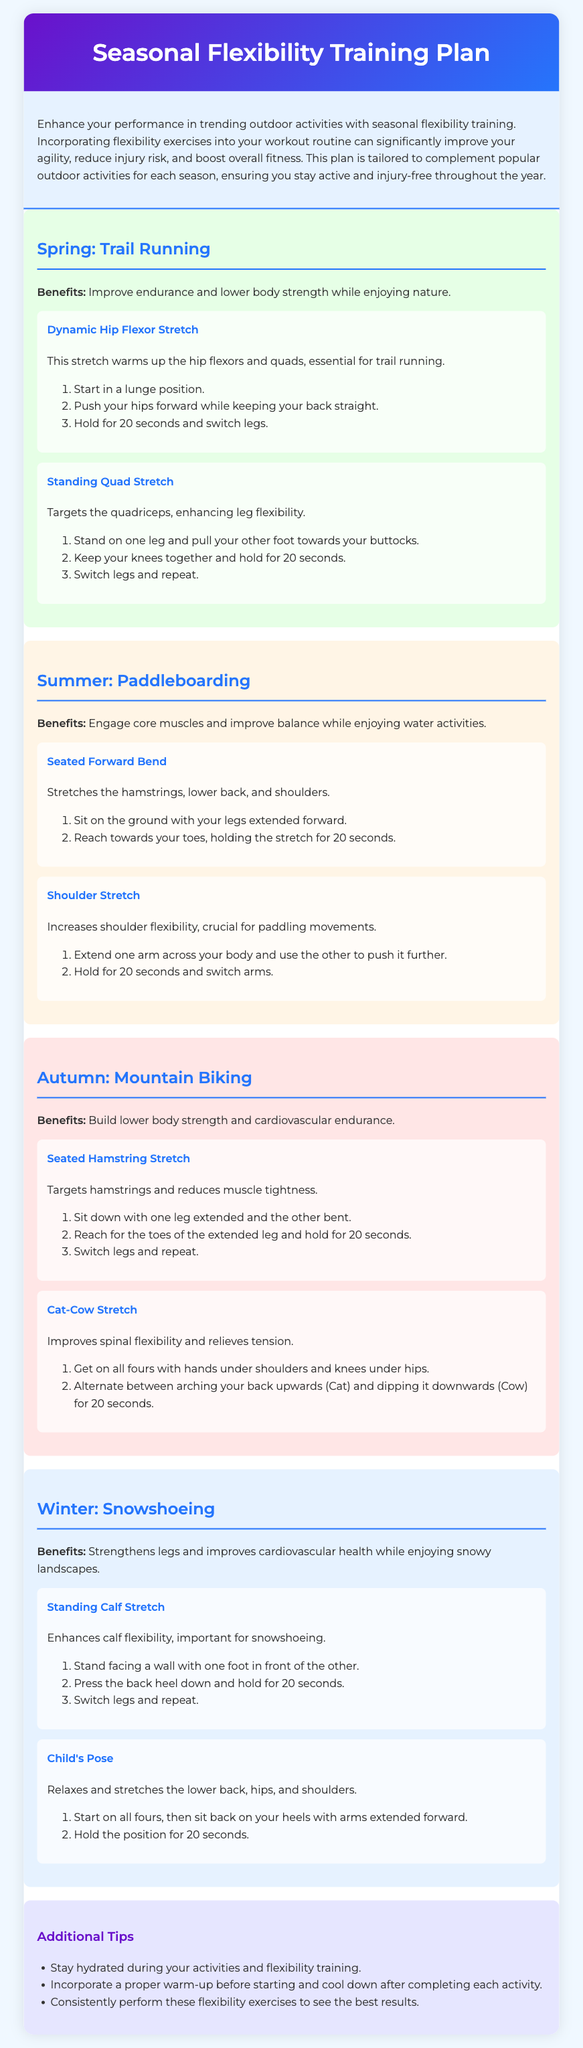What is the title of the document? The title of the document is mentioned in the header section.
Answer: Seasonal Flexibility Training Plan How many seasonal activities are covered in the document? The document outlines four seasonal activities in different sections.
Answer: Four What activity is suggested for summer? The specified activity for summer is detailed in the corresponding section.
Answer: Paddleboarding What is the benefit of the Dynamic Hip Flexor Stretch? The document states the benefits of each exercise within their sections.
Answer: Warms up the hip flexors and quads How long should you hold the Standing Quad Stretch? The duration for holding this stretch is specified in the exercise instructions.
Answer: 20 seconds Which exercise targets hamstrings specifically in the autumn section? The document provides the name of the exercise targeting hamstrings in that season.
Answer: Seated Hamstring Stretch What is a recommended tip mentioned in the document? The document includes various tips for enhancing workout effectiveness.
Answer: Stay hydrated Which season is associated with snowshoeing? The activity is linked to a specific season stated in the relevant section.
Answer: Winter 